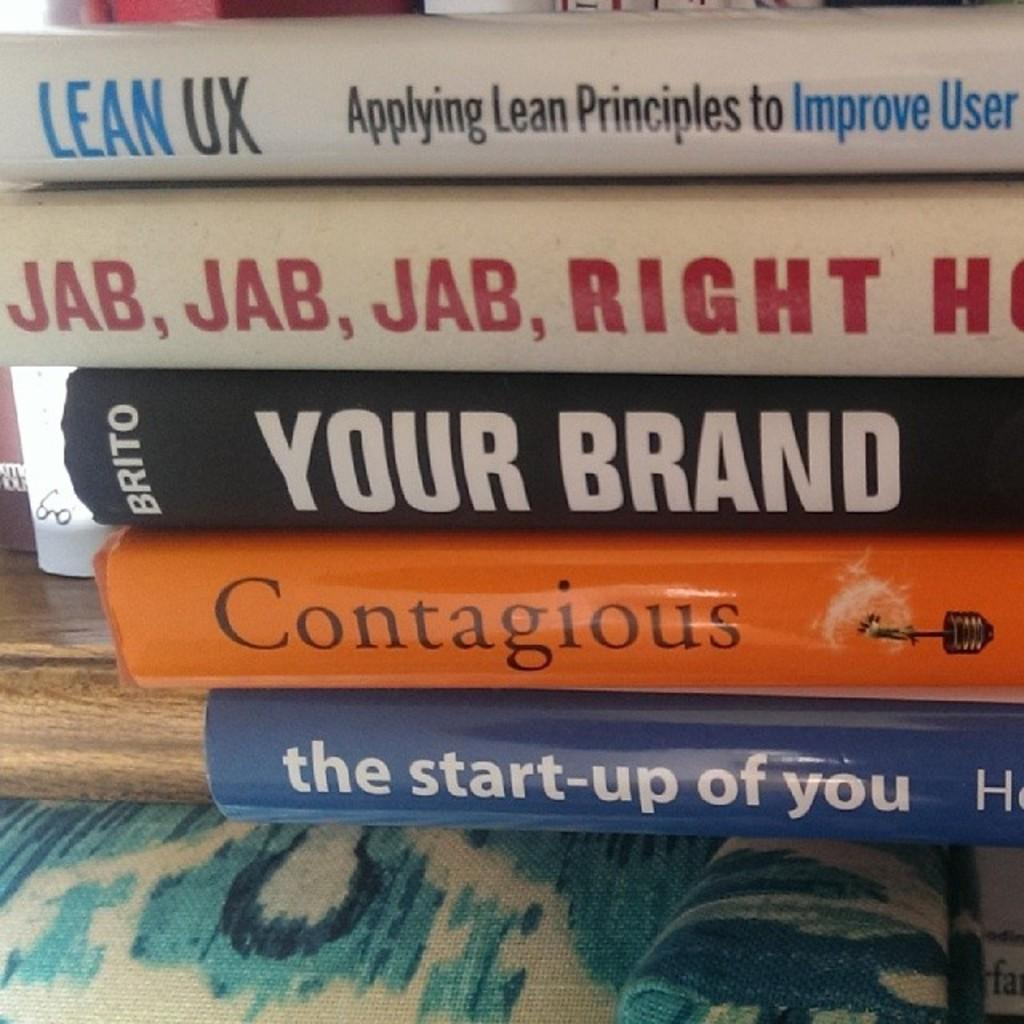<image>
Describe the image concisely. Five books are stacked on a table with a black book in the middle that is written by Brito called Your Brand. 